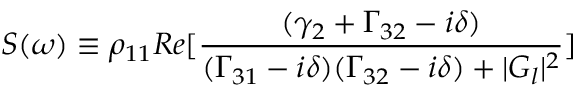<formula> <loc_0><loc_0><loc_500><loc_500>S ( \omega ) \equiv \rho _ { 1 1 } R e [ \frac { ( \gamma _ { 2 } + \Gamma _ { 3 2 } - i \delta ) } { ( \Gamma _ { 3 1 } - i \delta ) ( \Gamma _ { 3 2 } - i \delta ) + | G _ { l } | ^ { 2 } } ]</formula> 